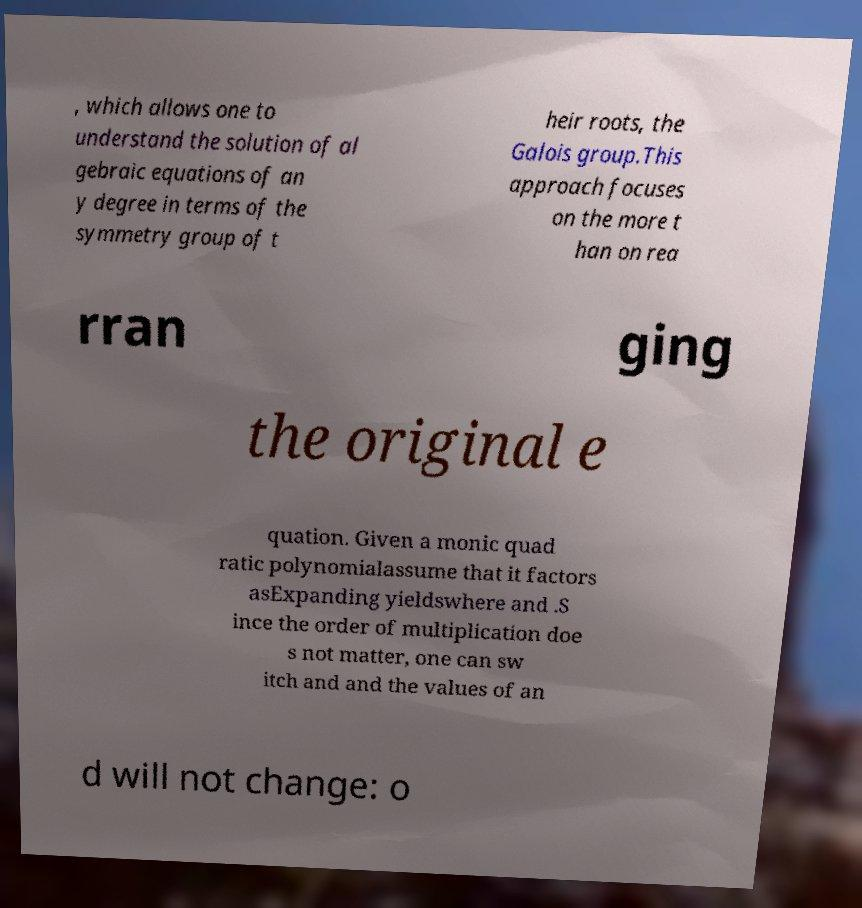Please read and relay the text visible in this image. What does it say? , which allows one to understand the solution of al gebraic equations of an y degree in terms of the symmetry group of t heir roots, the Galois group.This approach focuses on the more t han on rea rran ging the original e quation. Given a monic quad ratic polynomialassume that it factors asExpanding yieldswhere and .S ince the order of multiplication doe s not matter, one can sw itch and and the values of an d will not change: o 